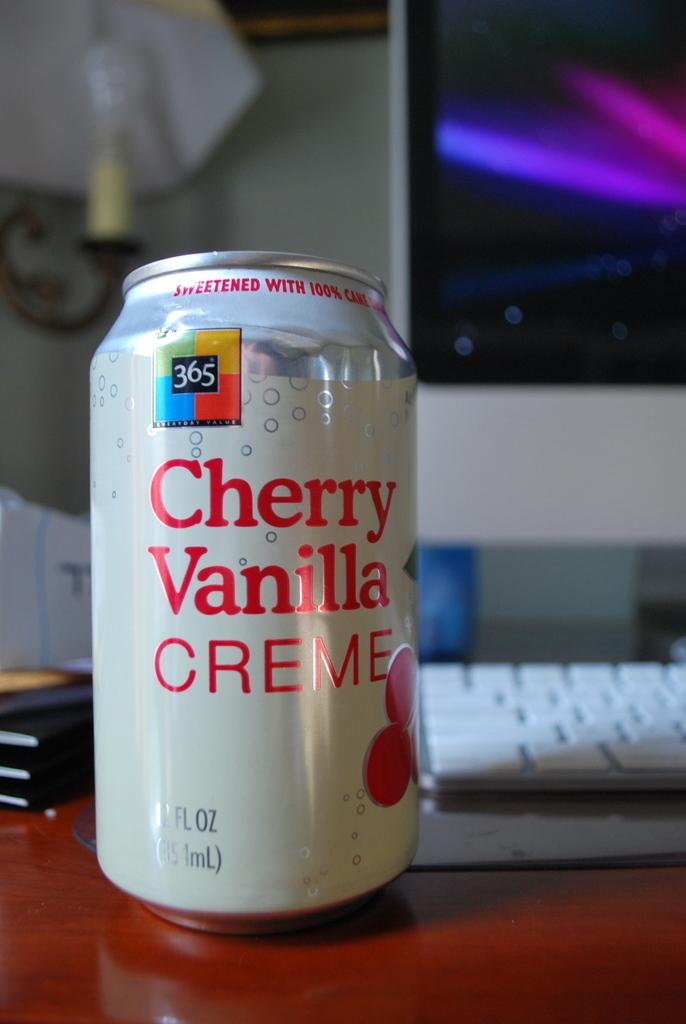<image>
Describe the image concisely. A cherry vanilla creme soda sits on a desk. 